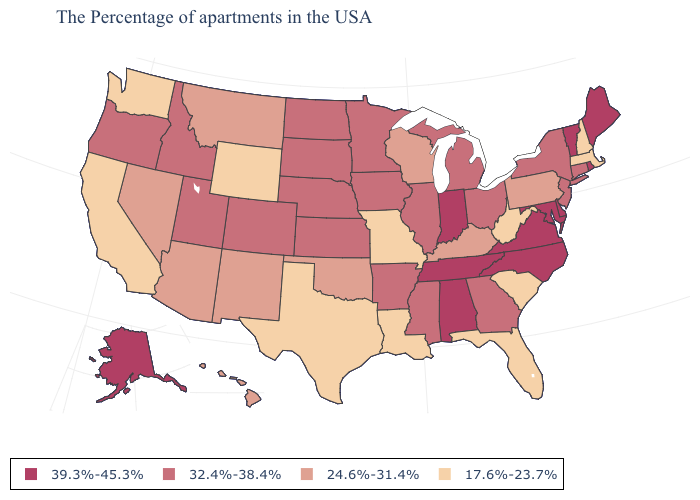Which states have the lowest value in the USA?
Quick response, please. Massachusetts, New Hampshire, South Carolina, West Virginia, Florida, Louisiana, Missouri, Texas, Wyoming, California, Washington. What is the value of Hawaii?
Give a very brief answer. 24.6%-31.4%. Does the map have missing data?
Quick response, please. No. How many symbols are there in the legend?
Short answer required. 4. Does the map have missing data?
Answer briefly. No. What is the value of Florida?
Answer briefly. 17.6%-23.7%. What is the highest value in states that border Georgia?
Be succinct. 39.3%-45.3%. What is the lowest value in the Northeast?
Keep it brief. 17.6%-23.7%. How many symbols are there in the legend?
Write a very short answer. 4. Does Indiana have the lowest value in the USA?
Concise answer only. No. Does Illinois have the highest value in the USA?
Short answer required. No. What is the value of Massachusetts?
Short answer required. 17.6%-23.7%. What is the highest value in the West ?
Short answer required. 39.3%-45.3%. Which states have the lowest value in the West?
Short answer required. Wyoming, California, Washington. 